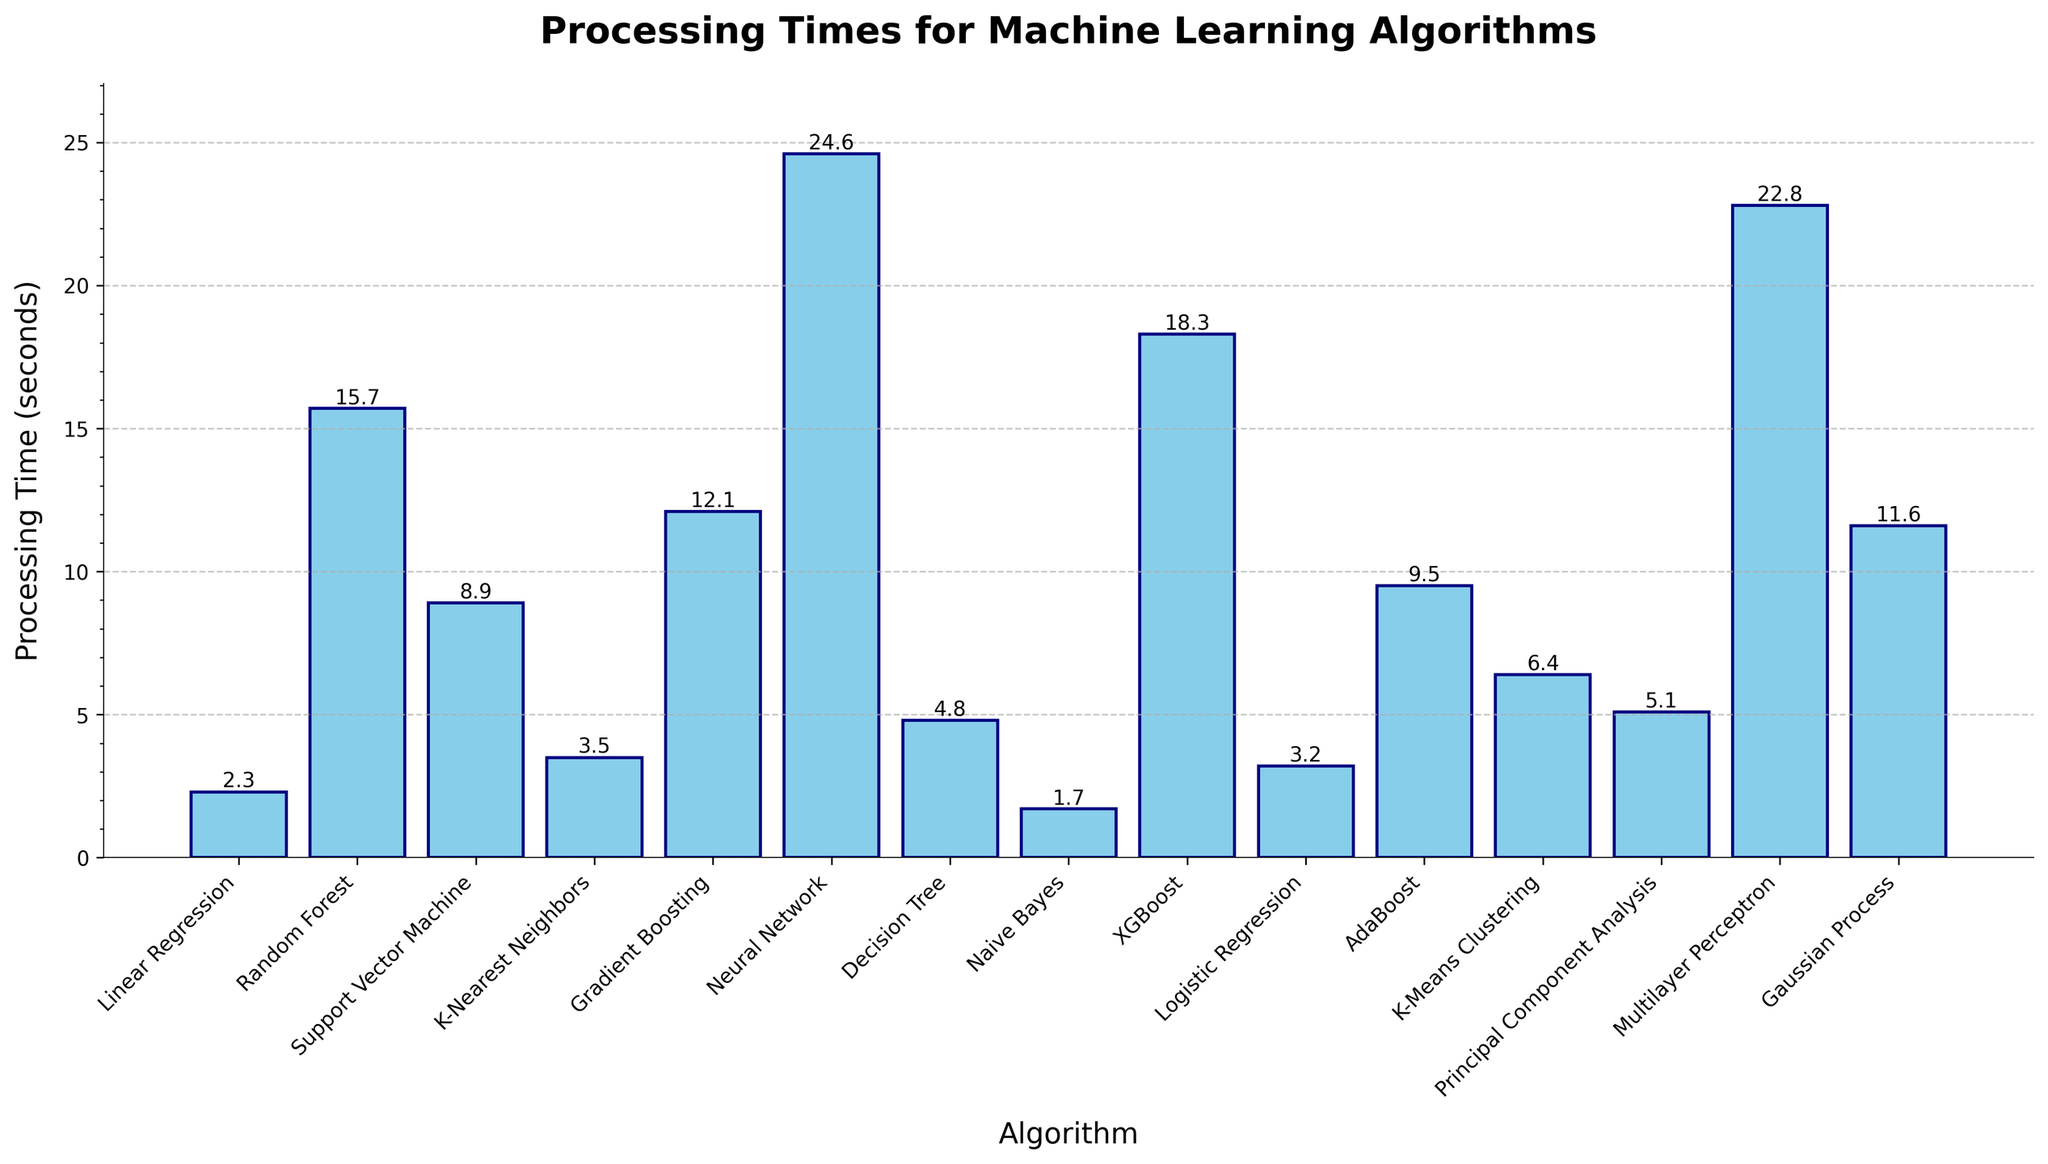Which algorithm has the longest processing time? The height of the bar representing the Neural Network is higher than all others, indicating it has the longest processing time.
Answer: Neural Network How much longer does the Neural Network take compared to the Naive Bayes algorithm? The processing time for Neural Network is 24.6 seconds, and for Naive Bayes, it is 1.7 seconds. The difference is 24.6 - 1.7 = 22.9 seconds.
Answer: 22.9 seconds Which two algorithms have the closest processing times? The bars for Gradient Boosting (12.1 seconds) and Gaussian Process (11.6 seconds) are very close in height, indicating similar processing times.
Answer: Gradient Boosting and Gaussian Process Sum the processing times of Random Forest, Support Vector Machine, and Gradient Boosting algorithms. Random Forest is 15.7 seconds, Support Vector Machine is 8.9 seconds, and Gradient Boosting is 12.1 seconds. The sum is 15.7 + 8.9 + 12.1 = 36.7 seconds.
Answer: 36.7 seconds What is the average processing time for all the algorithms? Sum all the processing times and divide by the number of algorithms. The sum is 155.0 seconds, and there are 15 algorithms. The average is 155.0 / 15 = 10.3 seconds.
Answer: 10.3 seconds Which algorithm has a processing time closest to the average processing time? The average processing time is 10.3 seconds. Gaussian Process has a processing time of 11.6 seconds, which is closest to the average.
Answer: Gaussian Process Identify any algorithms with processing times less than 3 seconds. The bars for Linear Regression (2.3 seconds) and Naive Bayes (1.7 seconds) are lower than 3 seconds.
Answer: Linear Regression and Naive Bayes Compare the processing time of K-Means Clustering and Principal Component Analysis. The bar for K-Means Clustering is slightly taller than that of Principal Component Analysis. K-Means Clustering is 6.4 seconds, and Principal Component Analysis is 5.1 seconds. K-Means Clustering is longer.
Answer: K-Means Clustering What is the total processing time for all algorithms with processing times greater than 10 seconds? The algorithms are Random Forest (15.7), Gradient Boosting (12.1), Neural Network (24.6), XGBoost (18.3), and Gaussian Process (11.6). The sum is 15.7 + 12.1 + 24.6 + 18.3 + 11.6 = 82.3 seconds.
Answer: 82.3 seconds Determine the median processing time. There are 15 data points. Ordering the times: [1.7, 2.3, 3.2, 3.5, 4.8, 5.1, 6.4, 8.9, 9.5, 11.6, 12.1, 15.7, 18.3, 22.8, 24.6], the median value is the 8th value, which is 8.9 seconds.
Answer: 8.9 seconds 